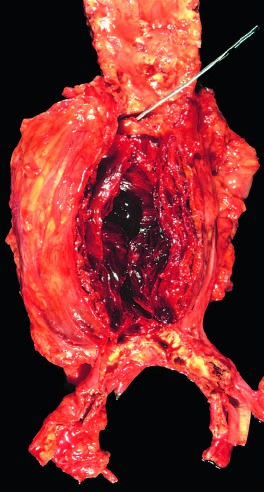what is attenuated?
Answer the question using a single word or phrase. The wall of the aneurysm 